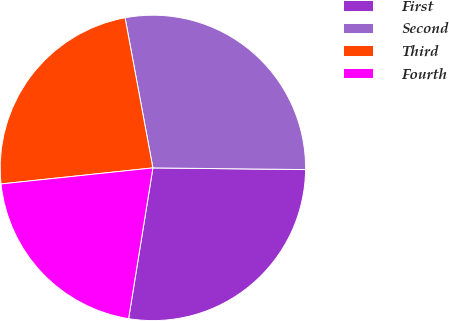Convert chart to OTSL. <chart><loc_0><loc_0><loc_500><loc_500><pie_chart><fcel>First<fcel>Second<fcel>Third<fcel>Fourth<nl><fcel>27.37%<fcel>28.09%<fcel>23.76%<fcel>20.78%<nl></chart> 